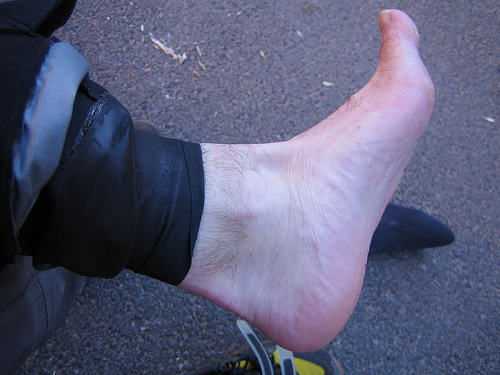<image>
Is the dirt in the floor? No. The dirt is not contained within the floor. These objects have a different spatial relationship. 